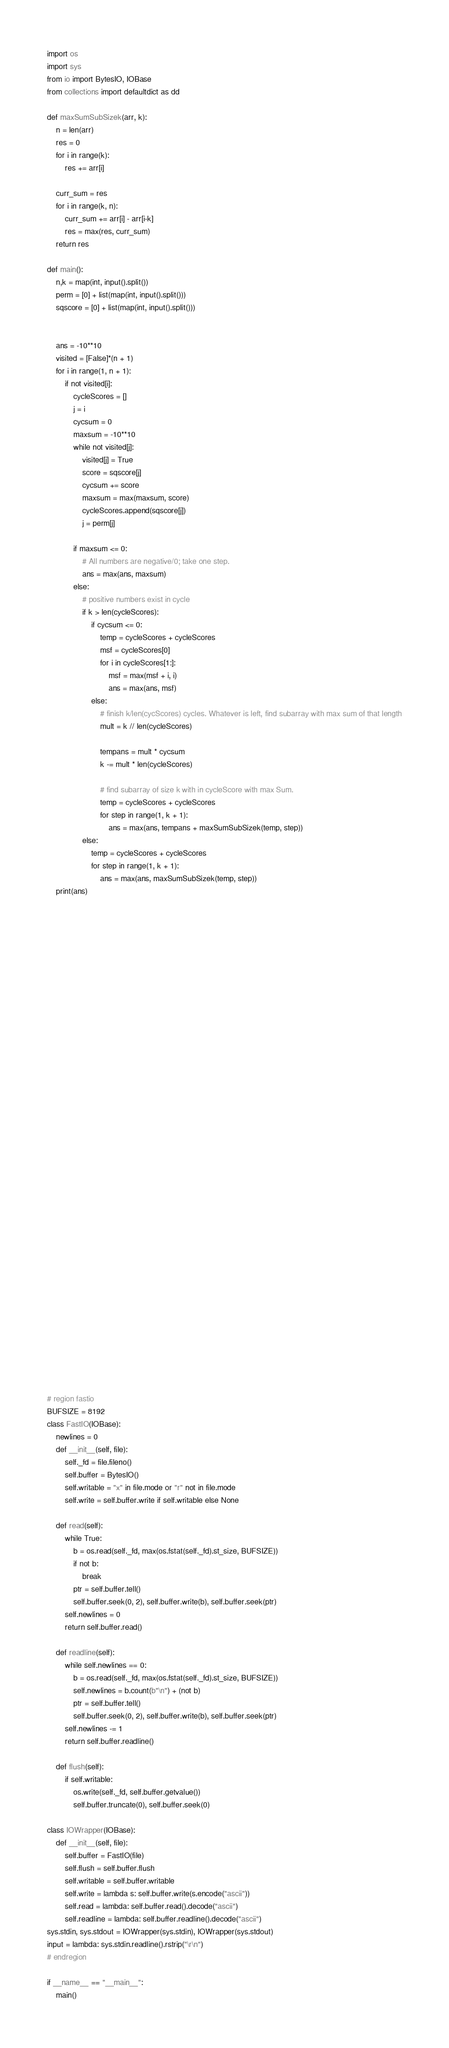<code> <loc_0><loc_0><loc_500><loc_500><_Python_>import os
import sys
from io import BytesIO, IOBase
from collections import defaultdict as dd

def maxSumSubSizek(arr, k): 
    n = len(arr)
    res = 0
    for i in range(k): 
        res += arr[i] 

    curr_sum = res 
    for i in range(k, n): 
        curr_sum += arr[i] - arr[i-k] 
        res = max(res, curr_sum) 
    return res 

def main():
    n,k = map(int, input().split())
    perm = [0] + list(map(int, input().split()))
    sqscore = [0] + list(map(int, input().split()))


    ans = -10**10
    visited = [False]*(n + 1)
    for i in range(1, n + 1):
        if not visited[i]:
            cycleScores = []
            j = i
            cycsum = 0
            maxsum = -10**10
            while not visited[j]:
                visited[j] = True
                score = sqscore[j]
                cycsum += score
                maxsum = max(maxsum, score)
                cycleScores.append(sqscore[j])
                j = perm[j]
            
            if maxsum <= 0:
                # All numbers are negative/0; take one step.
                ans = max(ans, maxsum)
            else:
                # positive numbers exist in cycle
                if k > len(cycleScores):
                    if cycsum <= 0:
                        temp = cycleScores + cycleScores
                        msf = cycleScores[0]
                        for i in cycleScores[1:]:
                            msf = max(msf + i, i)
                            ans = max(ans, msf)
                    else:
                        # finish k/len(cycScores) cycles. Whatever is left, find subarray with max sum of that length
                        mult = k // len(cycleScores)

                        tempans = mult * cycsum
                        k -= mult * len(cycleScores)
                        
                        # find subarray of size k with in cycleScore with max Sum.
                        temp = cycleScores + cycleScores
                        for step in range(1, k + 1):
                            ans = max(ans, tempans + maxSumSubSizek(temp, step))
                else:
                    temp = cycleScores + cycleScores
                    for step in range(1, k + 1):
                        ans = max(ans, maxSumSubSizek(temp, step))
    print(ans)


        




































# region fastio
BUFSIZE = 8192
class FastIO(IOBase):
    newlines = 0
    def __init__(self, file):
        self._fd = file.fileno()
        self.buffer = BytesIO()
        self.writable = "x" in file.mode or "r" not in file.mode
        self.write = self.buffer.write if self.writable else None
 
    def read(self):
        while True:
            b = os.read(self._fd, max(os.fstat(self._fd).st_size, BUFSIZE))
            if not b:
                break
            ptr = self.buffer.tell()
            self.buffer.seek(0, 2), self.buffer.write(b), self.buffer.seek(ptr)
        self.newlines = 0
        return self.buffer.read()
 
    def readline(self):
        while self.newlines == 0:
            b = os.read(self._fd, max(os.fstat(self._fd).st_size, BUFSIZE))
            self.newlines = b.count(b"\n") + (not b)
            ptr = self.buffer.tell()
            self.buffer.seek(0, 2), self.buffer.write(b), self.buffer.seek(ptr)
        self.newlines -= 1
        return self.buffer.readline()
 
    def flush(self):
        if self.writable:
            os.write(self._fd, self.buffer.getvalue())
            self.buffer.truncate(0), self.buffer.seek(0)

class IOWrapper(IOBase):
    def __init__(self, file):
        self.buffer = FastIO(file)
        self.flush = self.buffer.flush
        self.writable = self.buffer.writable
        self.write = lambda s: self.buffer.write(s.encode("ascii"))
        self.read = lambda: self.buffer.read().decode("ascii")
        self.readline = lambda: self.buffer.readline().decode("ascii")
sys.stdin, sys.stdout = IOWrapper(sys.stdin), IOWrapper(sys.stdout)
input = lambda: sys.stdin.readline().rstrip("\r\n")
# endregion
 
if __name__ == "__main__":
    main()</code> 